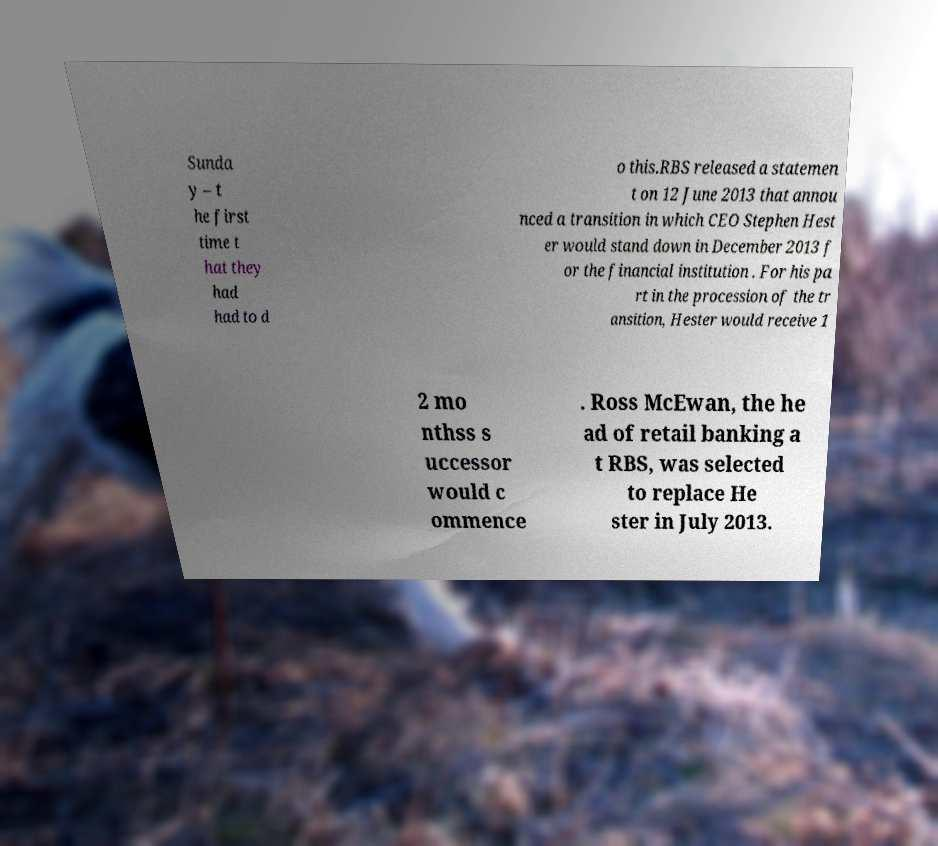Please read and relay the text visible in this image. What does it say? Sunda y – t he first time t hat they had had to d o this.RBS released a statemen t on 12 June 2013 that annou nced a transition in which CEO Stephen Hest er would stand down in December 2013 f or the financial institution . For his pa rt in the procession of the tr ansition, Hester would receive 1 2 mo nthss s uccessor would c ommence . Ross McEwan, the he ad of retail banking a t RBS, was selected to replace He ster in July 2013. 